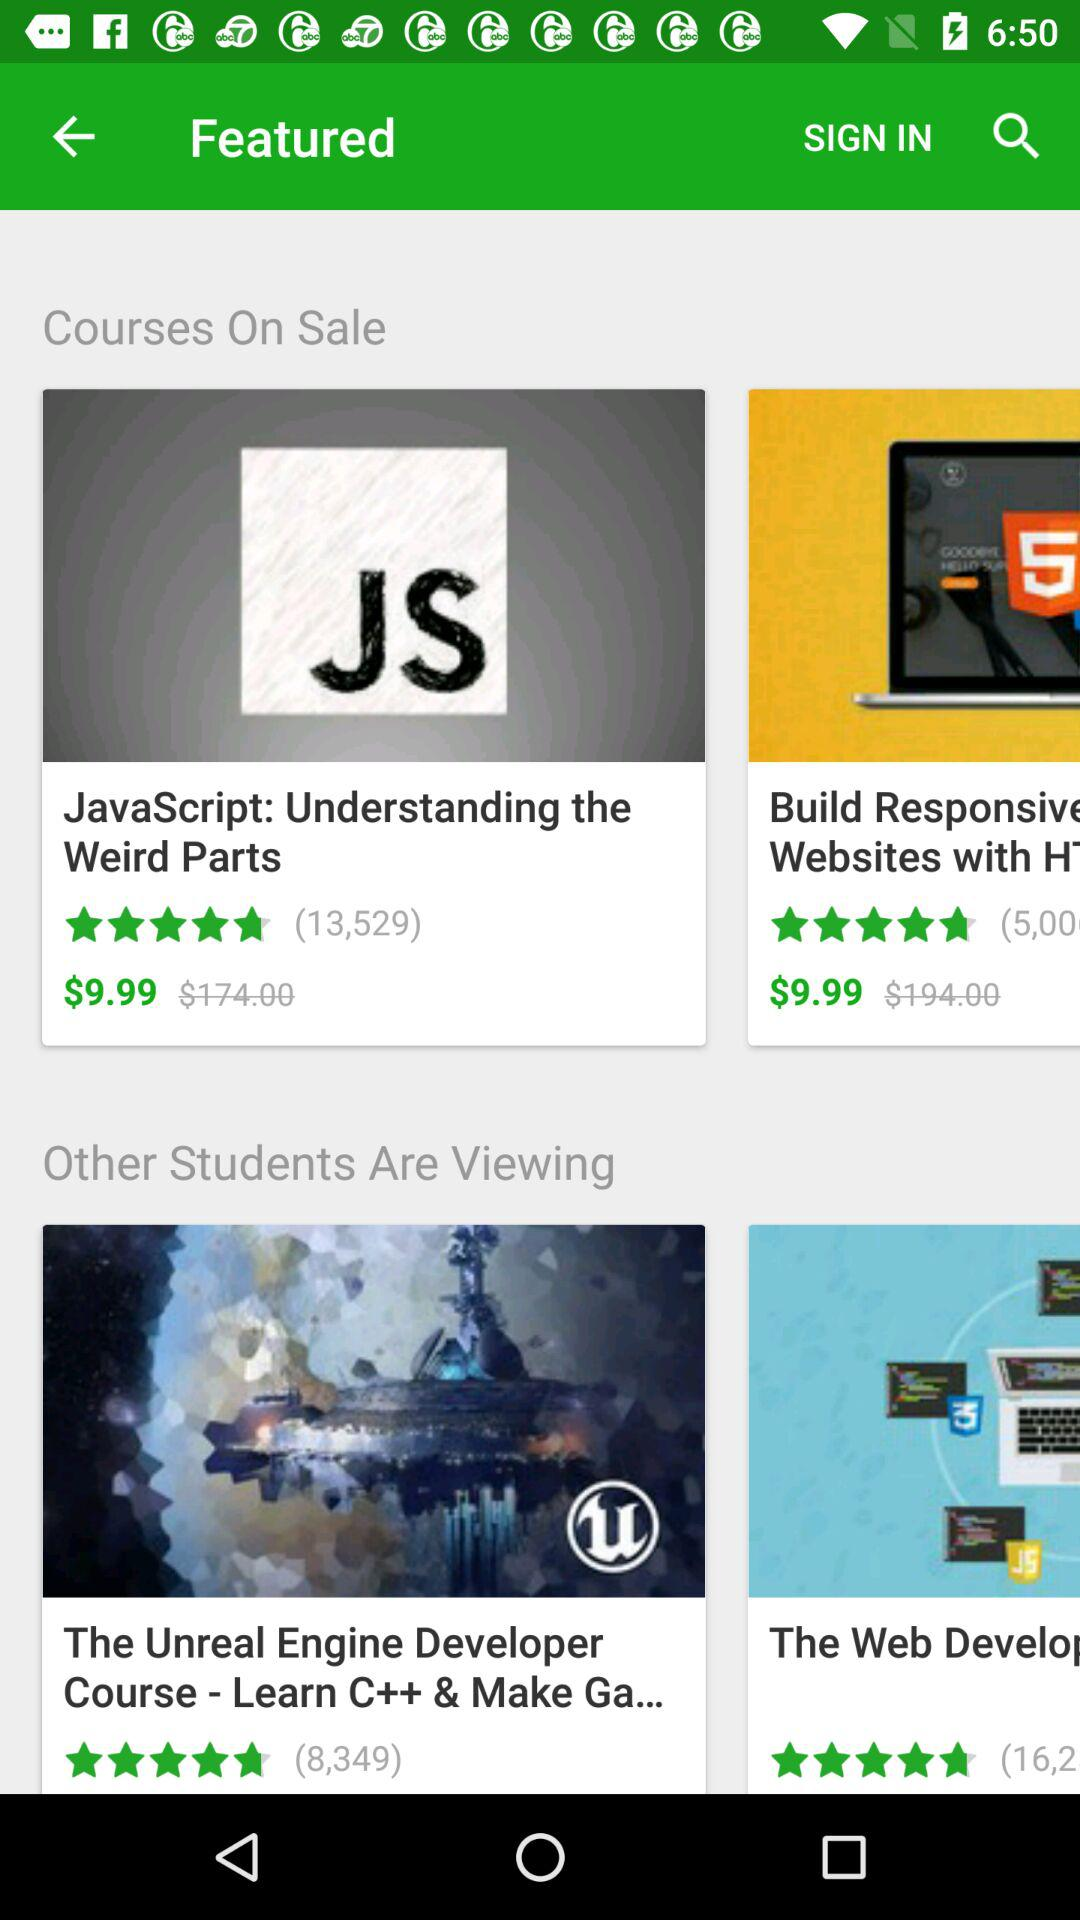How many courses have a price of $9.99?
Answer the question using a single word or phrase. 2 